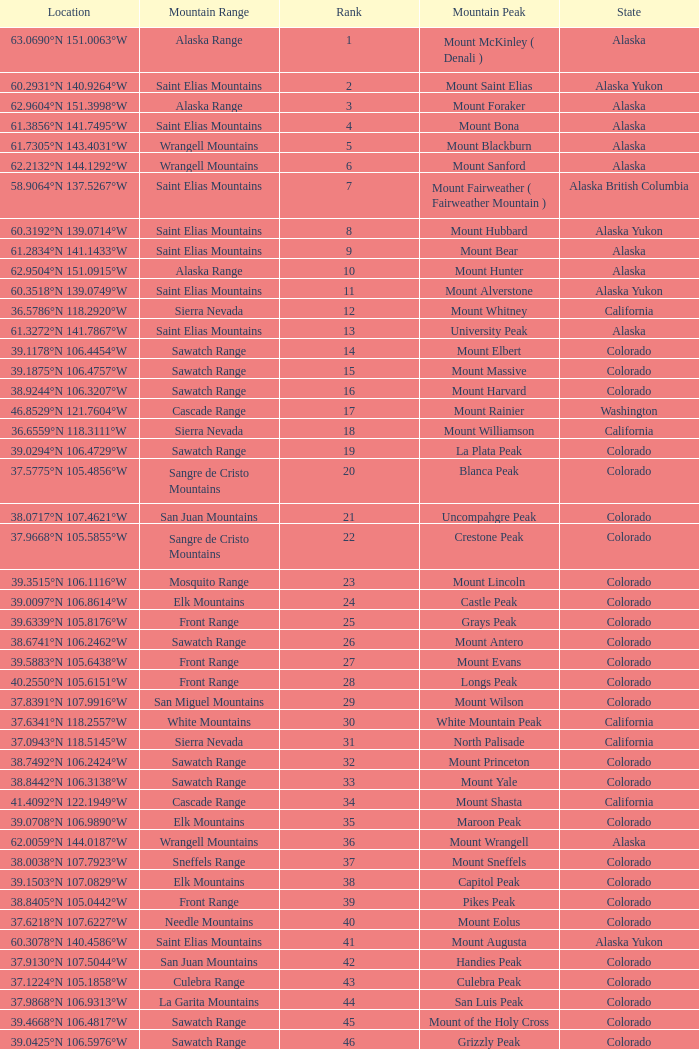What is the mountain range when the state is colorado, rank is higher than 90 and mountain peak is whetstone mountain? West Elk Mountains. 